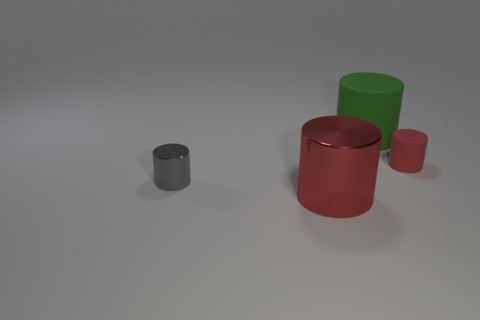What shape is the small thing left of the large thing that is in front of the red object to the right of the big green matte cylinder?
Your answer should be compact. Cylinder. Do the small cylinder right of the green rubber thing and the big cylinder that is in front of the big rubber thing have the same color?
Keep it short and to the point. Yes. How many small gray objects are there?
Your response must be concise. 1. There is a big matte thing; are there any large red metallic cylinders behind it?
Provide a succinct answer. No. Are the small cylinder that is in front of the red rubber cylinder and the big cylinder that is on the right side of the red metallic cylinder made of the same material?
Provide a succinct answer. No. Are there fewer tiny gray things that are in front of the red shiny cylinder than big cyan metal cylinders?
Offer a very short reply. No. What is the color of the rubber object that is to the left of the tiny rubber cylinder?
Your answer should be compact. Green. What material is the red object on the right side of the large cylinder that is behind the red rubber object made of?
Provide a short and direct response. Rubber. Are there any metal cylinders of the same size as the red matte cylinder?
Your answer should be compact. Yes. How many things are cylinders that are on the left side of the small rubber cylinder or things left of the red metallic cylinder?
Your answer should be compact. 3. 